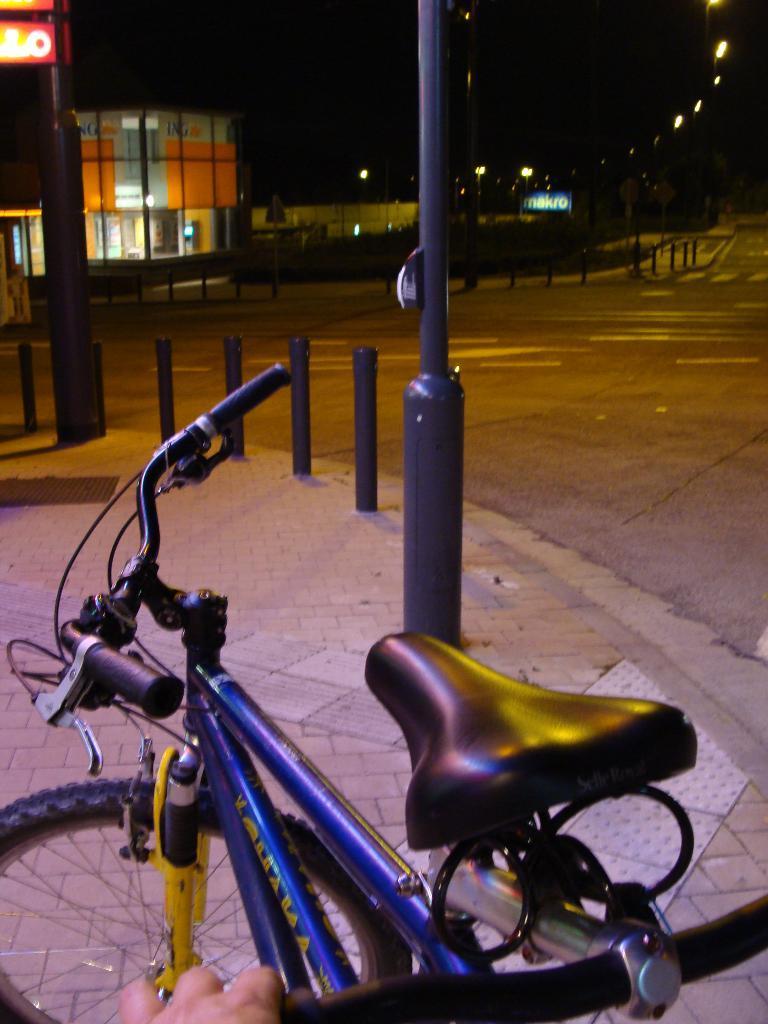Can you describe this image briefly? In this image I can see a bicycle. In front I can see few poles, building, boards, light poles and dark background. 